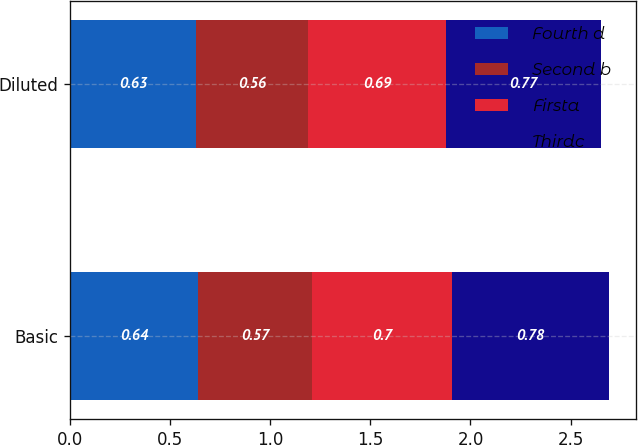Convert chart. <chart><loc_0><loc_0><loc_500><loc_500><stacked_bar_chart><ecel><fcel>Basic<fcel>Diluted<nl><fcel>Fourth d<fcel>0.64<fcel>0.63<nl><fcel>Second b<fcel>0.57<fcel>0.56<nl><fcel>Firsta<fcel>0.7<fcel>0.69<nl><fcel>Thirdc<fcel>0.78<fcel>0.77<nl></chart> 